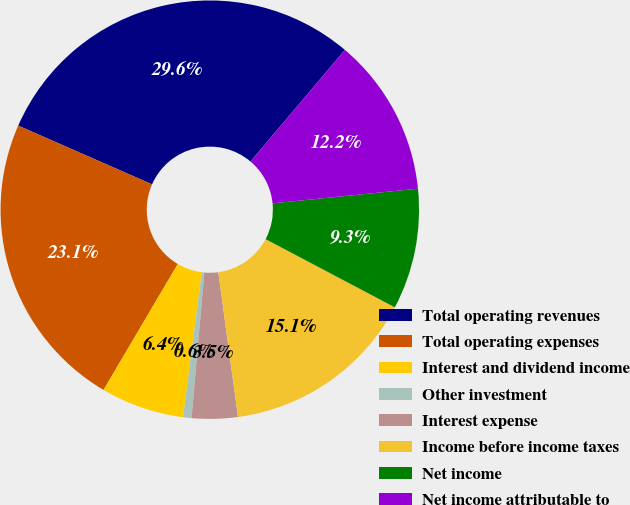<chart> <loc_0><loc_0><loc_500><loc_500><pie_chart><fcel>Total operating revenues<fcel>Total operating expenses<fcel>Interest and dividend income<fcel>Other investment<fcel>Interest expense<fcel>Income before income taxes<fcel>Net income<fcel>Net income attributable to<nl><fcel>29.59%<fcel>23.1%<fcel>6.44%<fcel>0.65%<fcel>3.54%<fcel>15.12%<fcel>9.33%<fcel>12.23%<nl></chart> 